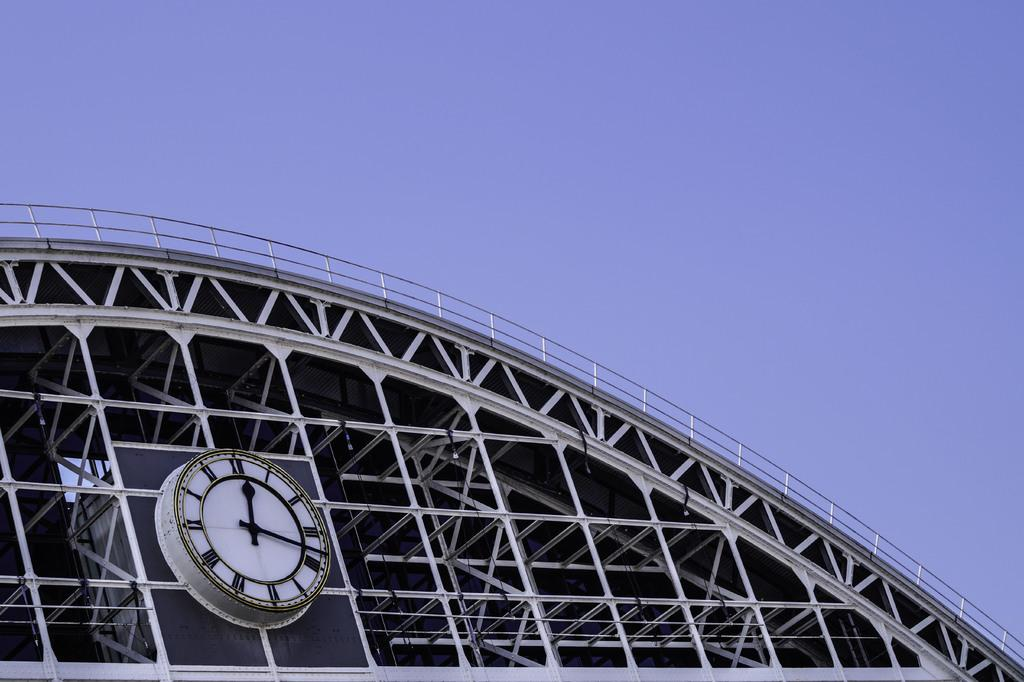What can be seen at the top of the image? The sky is visible towards the top of the image. What is located towards the bottom of the image? There is a building towards the bottom of the image. What feature is present on the building? There is a clock on the building. Can you see a sail in the image? There is no sail present in the image. Does the clock on the building have a smiley face? The image does not show the clock's face, so it cannot be determined if it has a smiley face or not. 